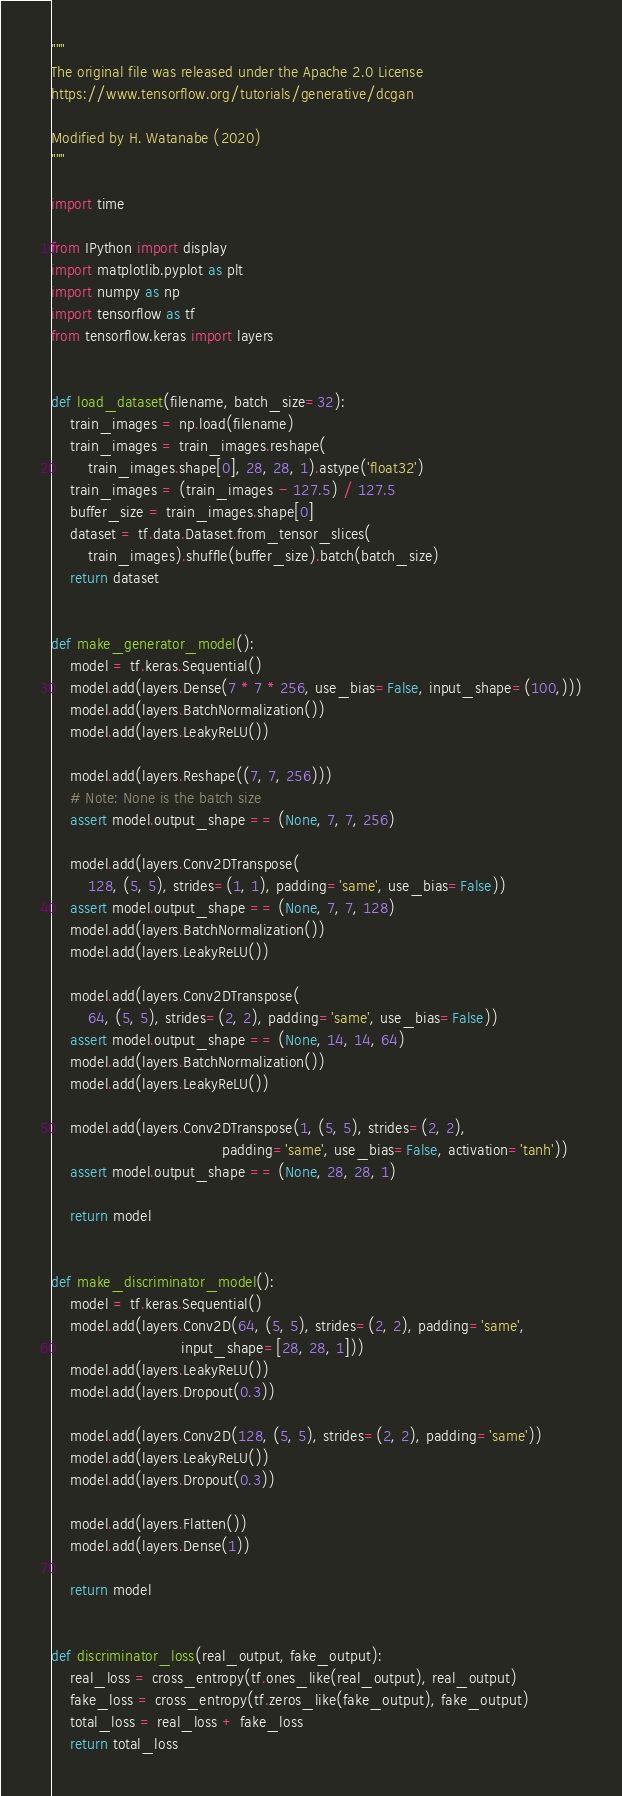Convert code to text. <code><loc_0><loc_0><loc_500><loc_500><_Python_>"""
The original file was released under the Apache 2.0 License
https://www.tensorflow.org/tutorials/generative/dcgan

Modified by H. Watanabe (2020)
"""

import time

from IPython import display
import matplotlib.pyplot as plt
import numpy as np
import tensorflow as tf
from tensorflow.keras import layers


def load_dataset(filename, batch_size=32):
    train_images = np.load(filename)
    train_images = train_images.reshape(
        train_images.shape[0], 28, 28, 1).astype('float32')
    train_images = (train_images - 127.5) / 127.5
    buffer_size = train_images.shape[0]
    dataset = tf.data.Dataset.from_tensor_slices(
        train_images).shuffle(buffer_size).batch(batch_size)
    return dataset


def make_generator_model():
    model = tf.keras.Sequential()
    model.add(layers.Dense(7 * 7 * 256, use_bias=False, input_shape=(100,)))
    model.add(layers.BatchNormalization())
    model.add(layers.LeakyReLU())

    model.add(layers.Reshape((7, 7, 256)))
    # Note: None is the batch size
    assert model.output_shape == (None, 7, 7, 256)

    model.add(layers.Conv2DTranspose(
        128, (5, 5), strides=(1, 1), padding='same', use_bias=False))
    assert model.output_shape == (None, 7, 7, 128)
    model.add(layers.BatchNormalization())
    model.add(layers.LeakyReLU())

    model.add(layers.Conv2DTranspose(
        64, (5, 5), strides=(2, 2), padding='same', use_bias=False))
    assert model.output_shape == (None, 14, 14, 64)
    model.add(layers.BatchNormalization())
    model.add(layers.LeakyReLU())

    model.add(layers.Conv2DTranspose(1, (5, 5), strides=(2, 2),
                                     padding='same', use_bias=False, activation='tanh'))
    assert model.output_shape == (None, 28, 28, 1)

    return model


def make_discriminator_model():
    model = tf.keras.Sequential()
    model.add(layers.Conv2D(64, (5, 5), strides=(2, 2), padding='same',
                            input_shape=[28, 28, 1]))
    model.add(layers.LeakyReLU())
    model.add(layers.Dropout(0.3))

    model.add(layers.Conv2D(128, (5, 5), strides=(2, 2), padding='same'))
    model.add(layers.LeakyReLU())
    model.add(layers.Dropout(0.3))

    model.add(layers.Flatten())
    model.add(layers.Dense(1))

    return model


def discriminator_loss(real_output, fake_output):
    real_loss = cross_entropy(tf.ones_like(real_output), real_output)
    fake_loss = cross_entropy(tf.zeros_like(fake_output), fake_output)
    total_loss = real_loss + fake_loss
    return total_loss

</code> 